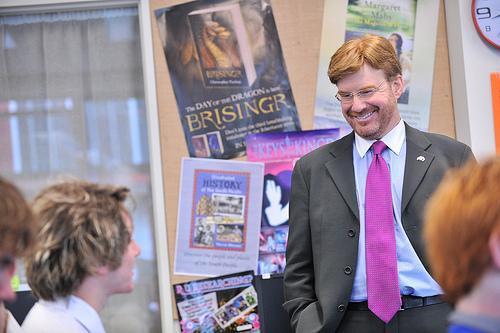How many people's heads can be seen?
Give a very brief answer. 4. How many different colors of hair can be seen?
Give a very brief answer. 3. How many windows are visible?
Give a very brief answer. 1. 